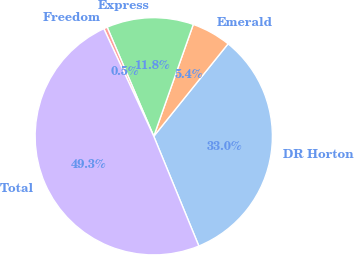<chart> <loc_0><loc_0><loc_500><loc_500><pie_chart><fcel>DR Horton<fcel>Emerald<fcel>Express<fcel>Freedom<fcel>Total<nl><fcel>33.02%<fcel>5.37%<fcel>11.83%<fcel>0.49%<fcel>49.29%<nl></chart> 